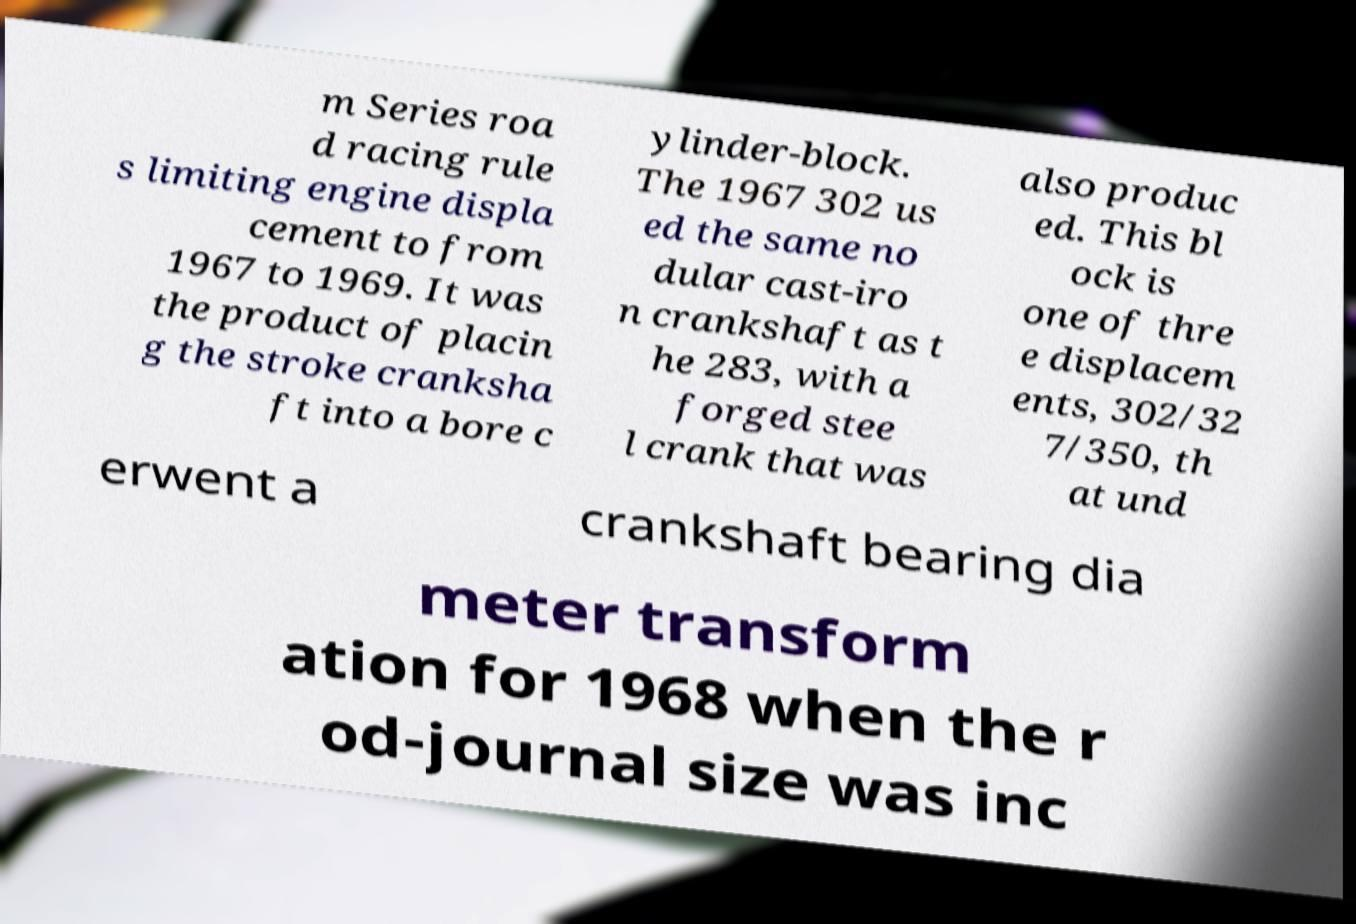Could you assist in decoding the text presented in this image and type it out clearly? m Series roa d racing rule s limiting engine displa cement to from 1967 to 1969. It was the product of placin g the stroke cranksha ft into a bore c ylinder-block. The 1967 302 us ed the same no dular cast-iro n crankshaft as t he 283, with a forged stee l crank that was also produc ed. This bl ock is one of thre e displacem ents, 302/32 7/350, th at und erwent a crankshaft bearing dia meter transform ation for 1968 when the r od-journal size was inc 